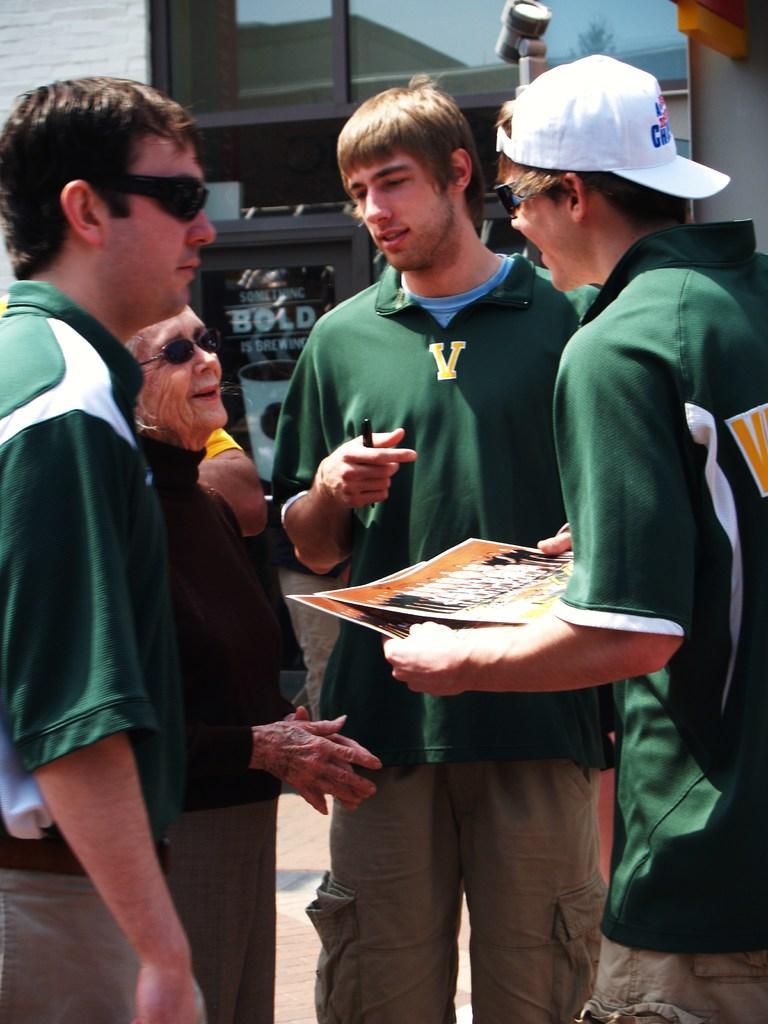Describe this image in one or two sentences. In this image there are people standing, one person is holding photographs in his hand, in the background there is a building. 